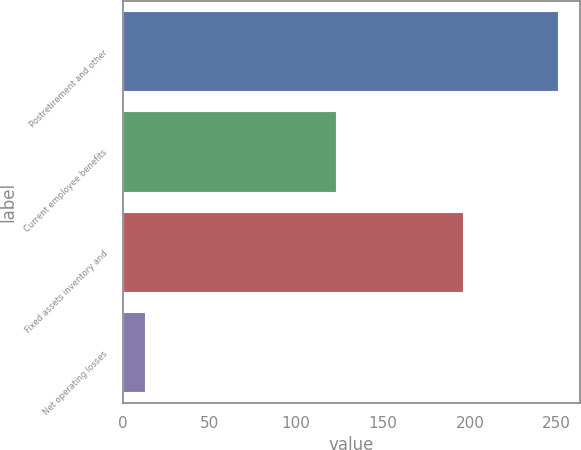Convert chart to OTSL. <chart><loc_0><loc_0><loc_500><loc_500><bar_chart><fcel>Postretirement and other<fcel>Current employee benefits<fcel>Fixed assets inventory and<fcel>Net operating losses<nl><fcel>251<fcel>123<fcel>196<fcel>13<nl></chart> 